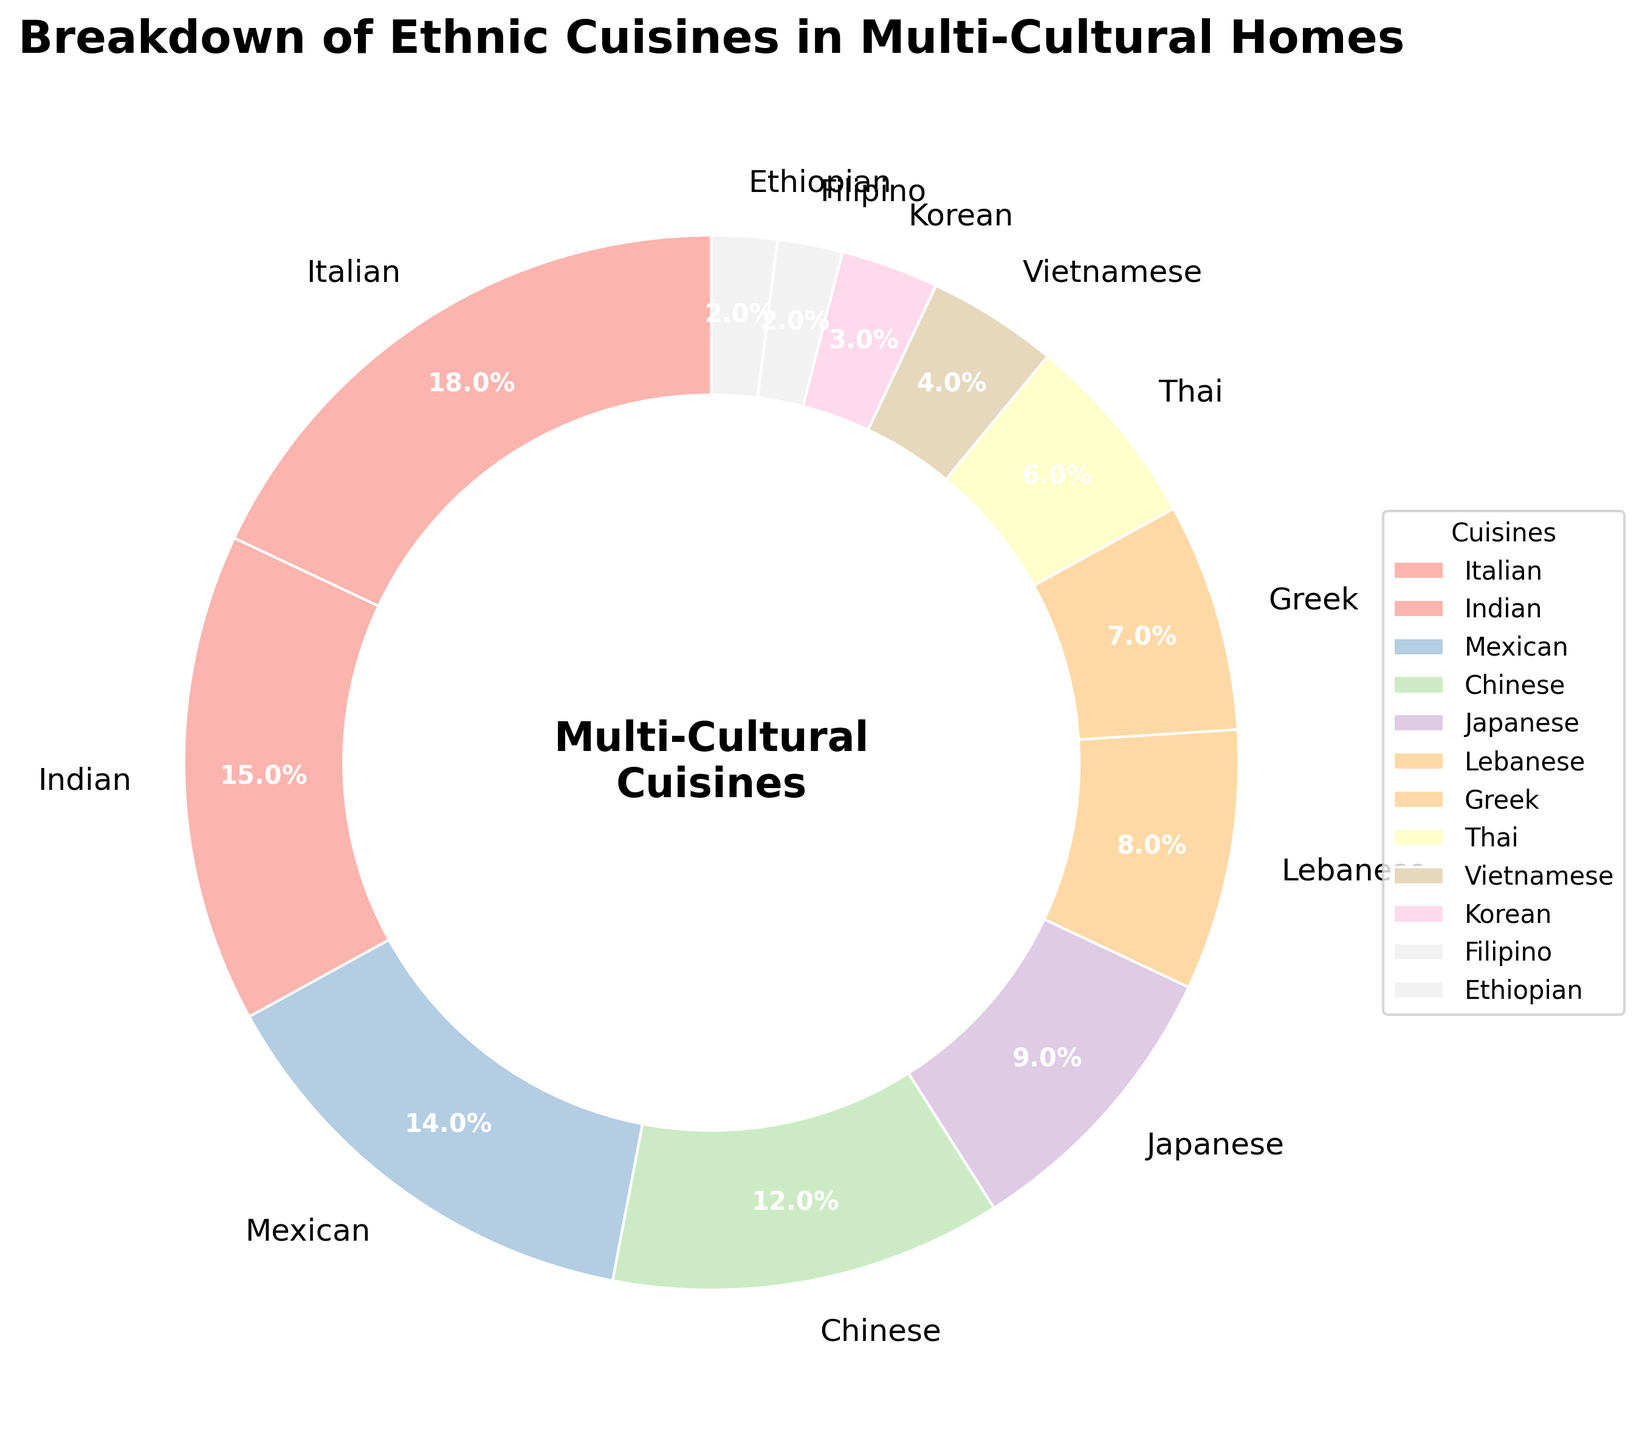What percentage of the cuisines are Italian and Mexican combined? To find the combined percentage of Italian and Mexican cuisines, add their individual percentages: 18% (Italian) + 14% (Mexican) = 32%.
Answer: 32% Which cuisine is more popular, Indian or Chinese? Compare the percentages of Indian cuisine (15%) and Chinese cuisine (12%). Since 15% is greater than 12%, Indian cuisine is more popular.
Answer: Indian What is the difference in the percentage points between Japanese and Korean cuisine? Subtract the percentage of Korean cuisine (3%) from Japanese cuisine (9%): 9% - 3% = 6%.
Answer: 6% Which cuisine category had the least representation? The cuisine with the smallest percentage in the chart is the least represented. Filipino and Ethiopian cuisines both have 2%.
Answer: Filipino and Ethiopian What is the average percentage of the top three most represented cuisines? Sum the top three percentages: Italian (18%), Indian (15%), and Mexican (14%): 18% + 15% + 14% = 47%. Then divide by 3: 47% / 3 = 15.67% (rounded to two decimal places).
Answer: 15.67% Are the combined percentages of Greek and Thai cuisines greater than the percentage of Chinese cuisine? Add the percentages of Greek (7%) and Thai (6%) cuisines: 7% + 6% = 13%. Compare 13% with Chinese cuisine (12%). Since 13% is greater, the combined percentage is greater.
Answer: Yes Which color represents Vietnamese cuisine? Identify the color corresponding to the Vietnamese cuisine from the pie chart based purely on the visual map. According to the data, Vietnamese is aligned with a specific pastel color, which would visually match in the chart.
Answer: [Infers from the pie chart] What is the sum of the percentages for all cuisines except the top three? First, find the percentages for the top three: Italian (18%), Indian (15%), and Mexican (14%). Sum them: 18% + 15% + 14% = 47%. Subtract from 100%: 100% - 47% = 53%.
Answer: 53% What is the ratio of the percentage of Japanese cuisine to Filipino cuisine? Divide the percentage of Japanese cuisine (9%) by Filipino cuisine (2%): 9 / 2 = 4.5.
Answer: 4.5 Which two cuisines combined make up approximately one-fourth of the total percentage? One-fourth of 100% is 25%. Look for two cuisines whose combined percentages approximate 25%. Chinese (12%) and Japanese (9%) make 21%; however, Mexican (14%) and Lebanese (8%) make 22%.
Answer: Mexican and Lebanese 